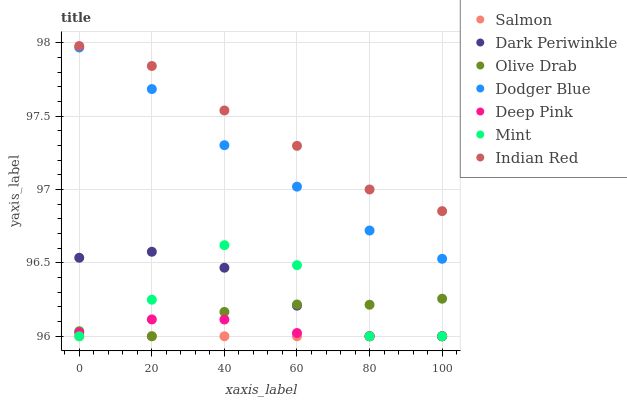Does Salmon have the minimum area under the curve?
Answer yes or no. Yes. Does Indian Red have the maximum area under the curve?
Answer yes or no. Yes. Does Dodger Blue have the minimum area under the curve?
Answer yes or no. No. Does Dodger Blue have the maximum area under the curve?
Answer yes or no. No. Is Salmon the smoothest?
Answer yes or no. Yes. Is Mint the roughest?
Answer yes or no. Yes. Is Dodger Blue the smoothest?
Answer yes or no. No. Is Dodger Blue the roughest?
Answer yes or no. No. Does Deep Pink have the lowest value?
Answer yes or no. Yes. Does Dodger Blue have the lowest value?
Answer yes or no. No. Does Indian Red have the highest value?
Answer yes or no. Yes. Does Dodger Blue have the highest value?
Answer yes or no. No. Is Dark Periwinkle less than Indian Red?
Answer yes or no. Yes. Is Indian Red greater than Dark Periwinkle?
Answer yes or no. Yes. Does Olive Drab intersect Salmon?
Answer yes or no. Yes. Is Olive Drab less than Salmon?
Answer yes or no. No. Is Olive Drab greater than Salmon?
Answer yes or no. No. Does Dark Periwinkle intersect Indian Red?
Answer yes or no. No. 